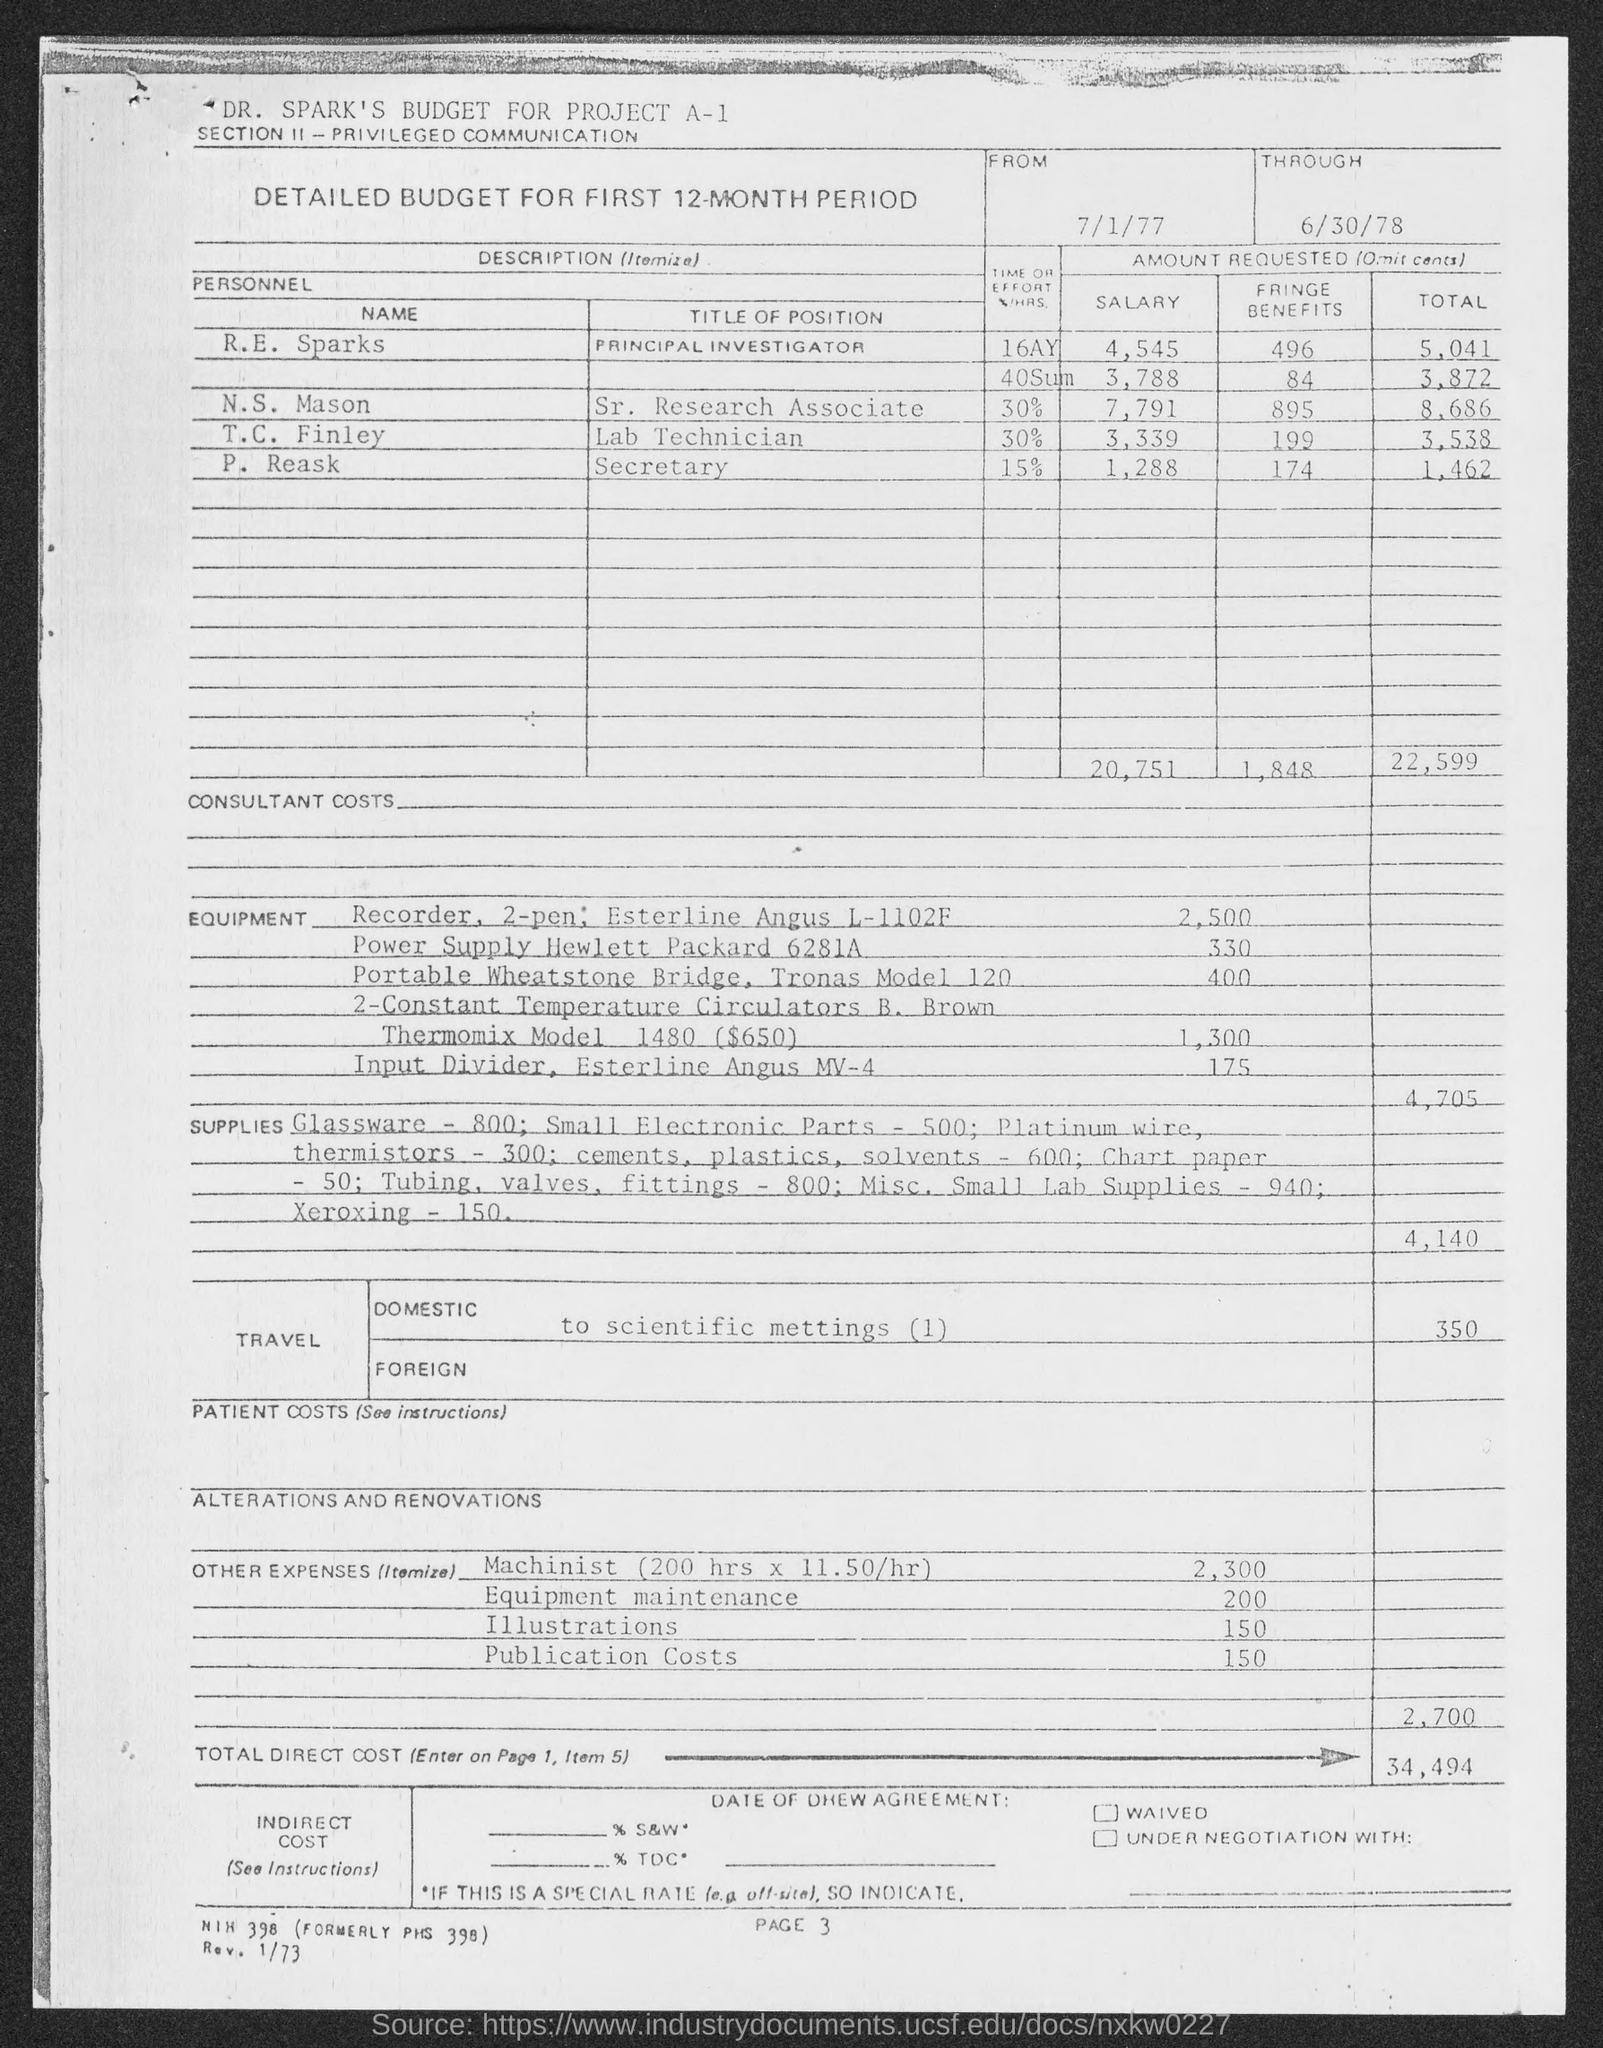What is the title of position of R.E. Sparks given in the document?
Provide a short and direct response. Principal Investigator. What is the time or effort(%/HRS) devoted by N.S. Mason for the project?
Your response must be concise. 30%. What is the title of position of P. Reask given in the document?
Offer a very short reply. Secretary. What is the time or effort(%/HRS) devoted by P. Reask for the project?
Your answer should be compact. 15%. What is the total amount requested by T.C. Finley as per the document?
Give a very brief answer. 3,538. What is the page no mentioned in the document?
Offer a very short reply. Page 3. 